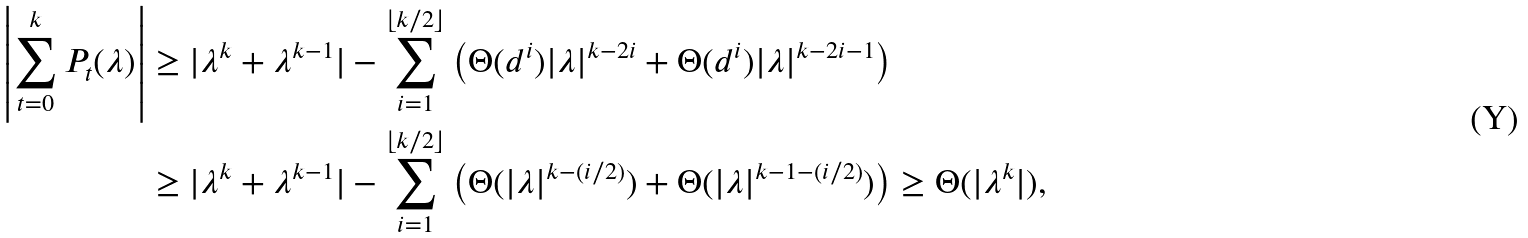Convert formula to latex. <formula><loc_0><loc_0><loc_500><loc_500>\left | \sum _ { t = 0 } ^ { k } P _ { t } ( \lambda ) \right | & \geq | \lambda ^ { k } + \lambda ^ { k - 1 } | - \sum _ { i = 1 } ^ { \lfloor k / 2 \rfloor } \left ( \Theta ( d ^ { i } ) | \lambda | ^ { k - 2 i } + \Theta ( d ^ { i } ) | \lambda | ^ { k - 2 i - 1 } \right ) \\ & \geq | \lambda ^ { k } + \lambda ^ { k - 1 } | - \sum _ { i = 1 } ^ { \lfloor k / 2 \rfloor } \left ( \Theta ( | \lambda | ^ { k - ( i / 2 ) } ) + \Theta ( | \lambda | ^ { k - 1 - ( i / 2 ) } ) \right ) \geq \Theta ( | \lambda ^ { k } | ) ,</formula> 